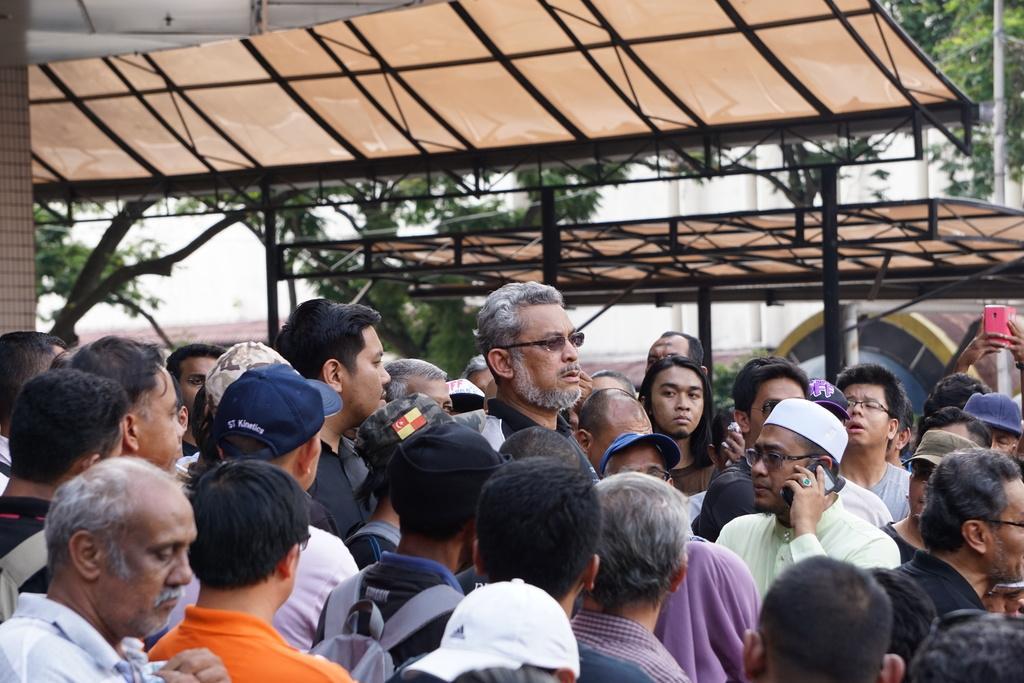Please provide a concise description of this image. In the foreground of the picture there are group of people. In the middle of the picture we can see sheds and trees. In the background there are poles and a wall. 